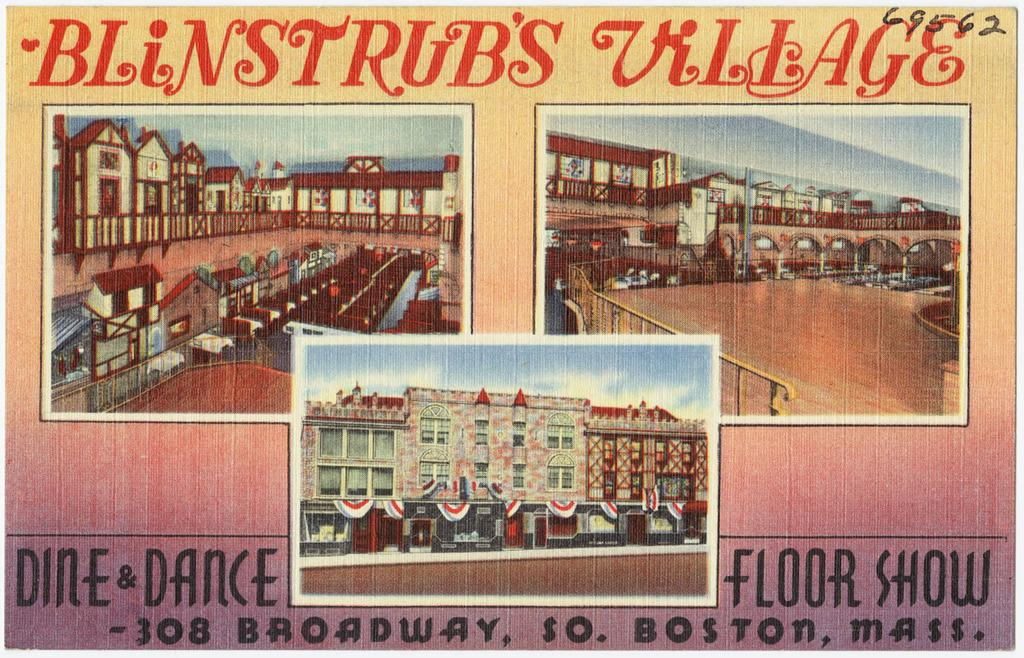<image>
Offer a succinct explanation of the picture presented. Dine and Dance in Blinstrub's Village in Boston. 